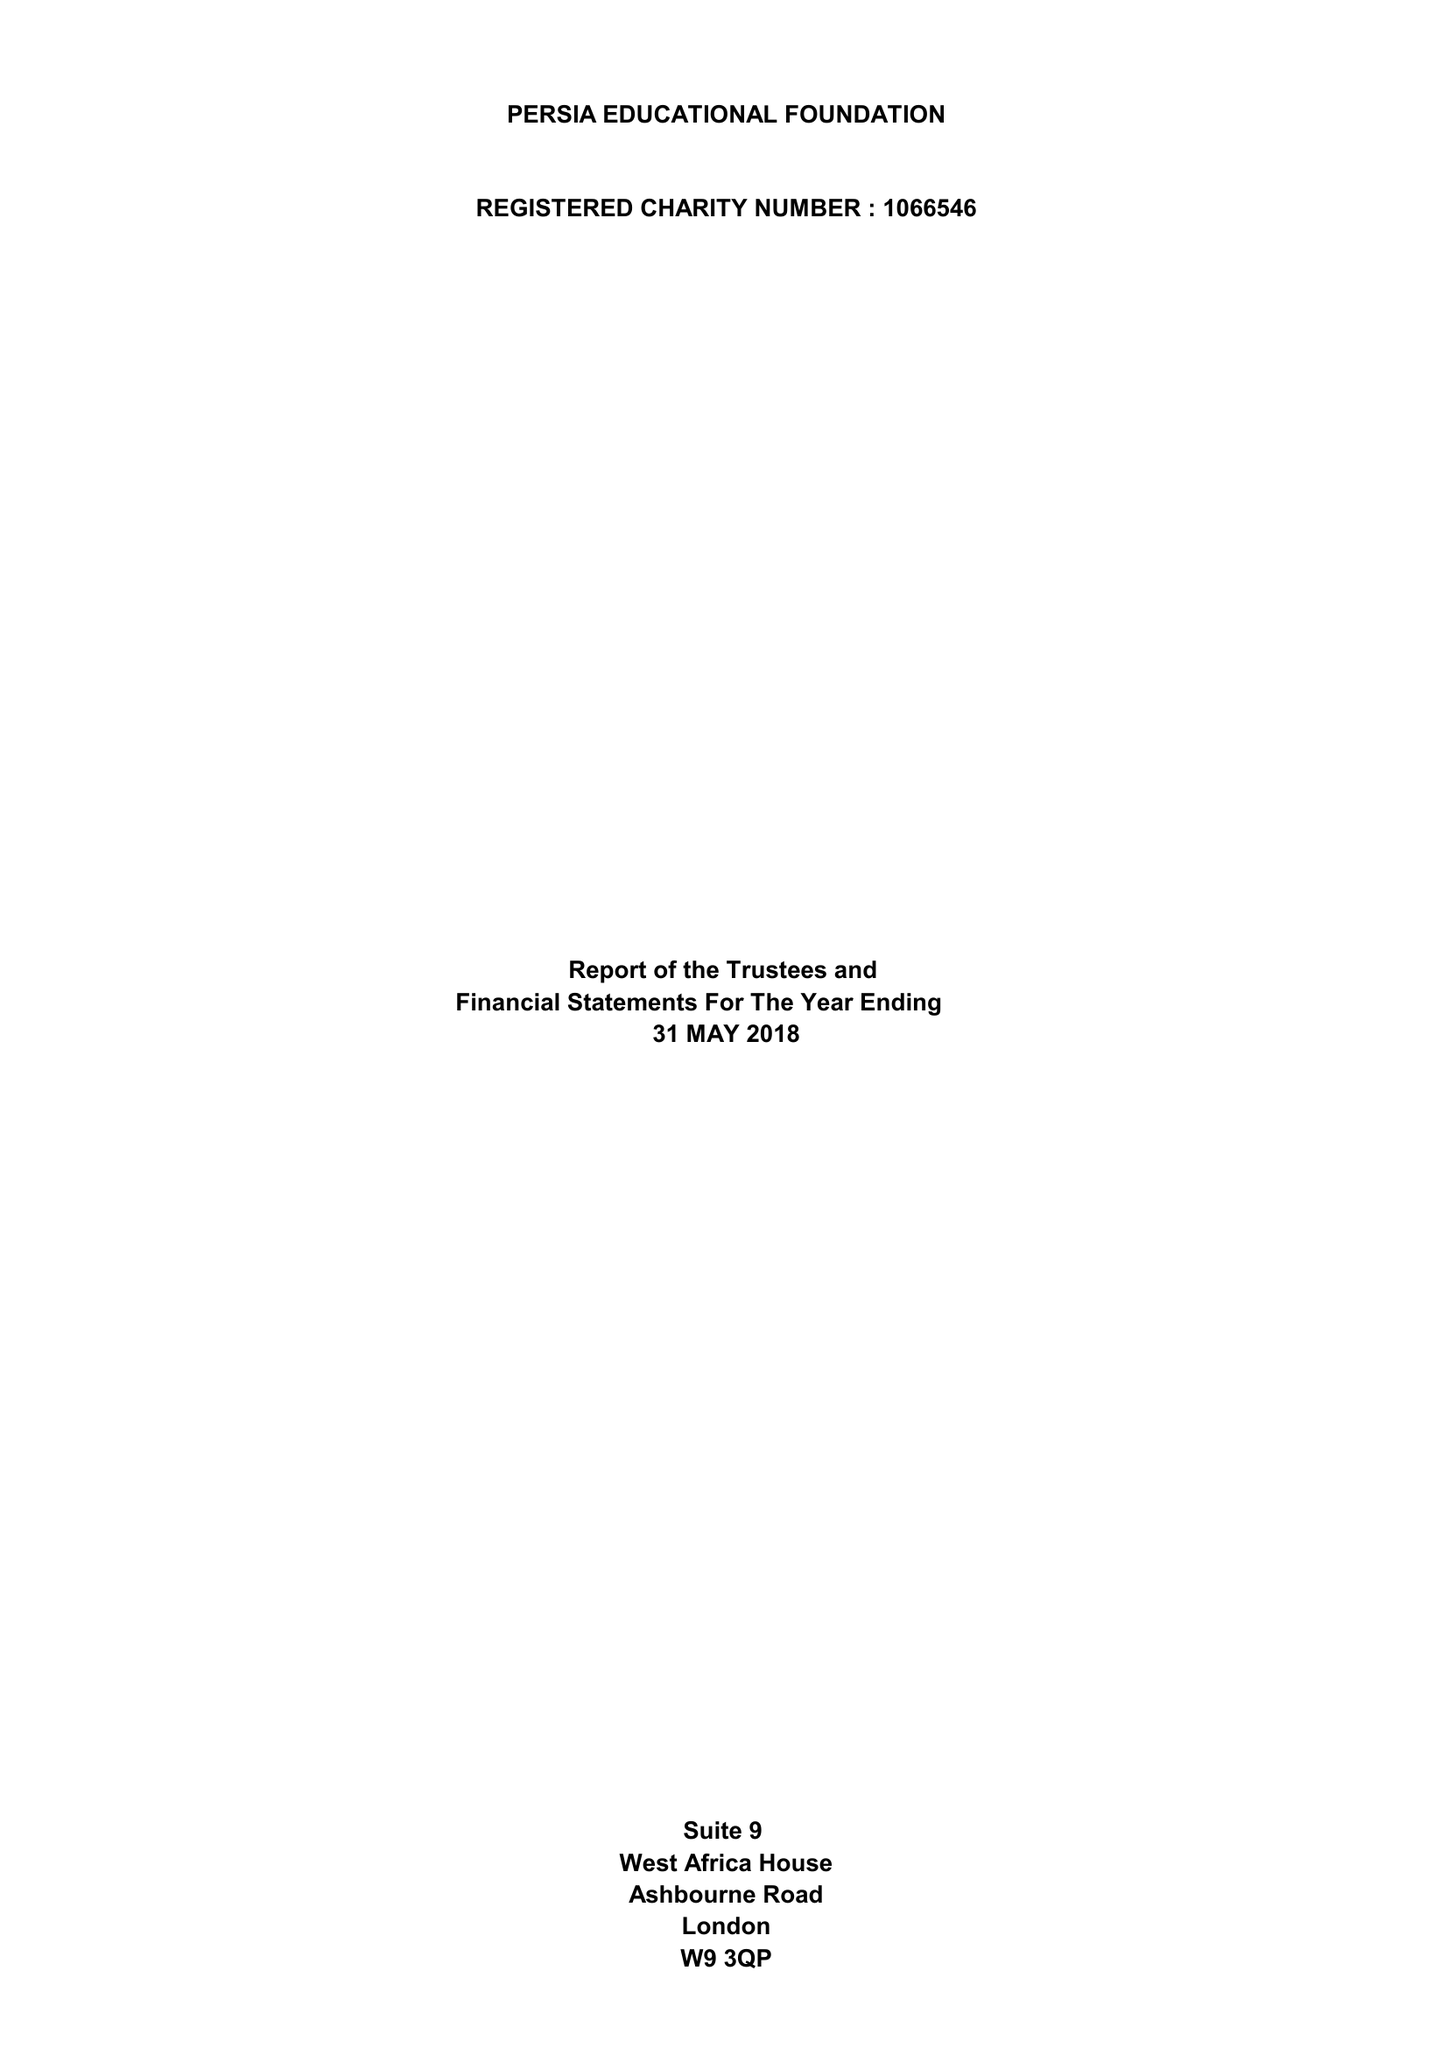What is the value for the income_annually_in_british_pounds?
Answer the question using a single word or phrase. 82859.00 